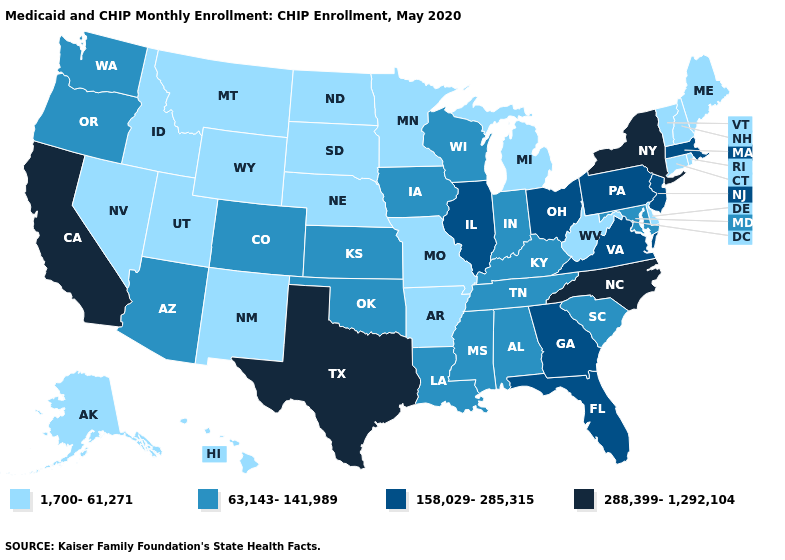Which states have the lowest value in the USA?
Give a very brief answer. Alaska, Arkansas, Connecticut, Delaware, Hawaii, Idaho, Maine, Michigan, Minnesota, Missouri, Montana, Nebraska, Nevada, New Hampshire, New Mexico, North Dakota, Rhode Island, South Dakota, Utah, Vermont, West Virginia, Wyoming. Among the states that border Iowa , does Minnesota have the lowest value?
Give a very brief answer. Yes. What is the highest value in the West ?
Keep it brief. 288,399-1,292,104. Among the states that border Texas , does Louisiana have the lowest value?
Short answer required. No. What is the lowest value in the South?
Write a very short answer. 1,700-61,271. Is the legend a continuous bar?
Short answer required. No. Does Kansas have the lowest value in the USA?
Answer briefly. No. Does Kansas have the same value as California?
Short answer required. No. What is the value of Washington?
Keep it brief. 63,143-141,989. What is the highest value in the MidWest ?
Keep it brief. 158,029-285,315. What is the value of Kansas?
Be succinct. 63,143-141,989. Name the states that have a value in the range 63,143-141,989?
Write a very short answer. Alabama, Arizona, Colorado, Indiana, Iowa, Kansas, Kentucky, Louisiana, Maryland, Mississippi, Oklahoma, Oregon, South Carolina, Tennessee, Washington, Wisconsin. Name the states that have a value in the range 288,399-1,292,104?
Quick response, please. California, New York, North Carolina, Texas. Which states have the lowest value in the USA?
Answer briefly. Alaska, Arkansas, Connecticut, Delaware, Hawaii, Idaho, Maine, Michigan, Minnesota, Missouri, Montana, Nebraska, Nevada, New Hampshire, New Mexico, North Dakota, Rhode Island, South Dakota, Utah, Vermont, West Virginia, Wyoming. Among the states that border Pennsylvania , does West Virginia have the lowest value?
Short answer required. Yes. 